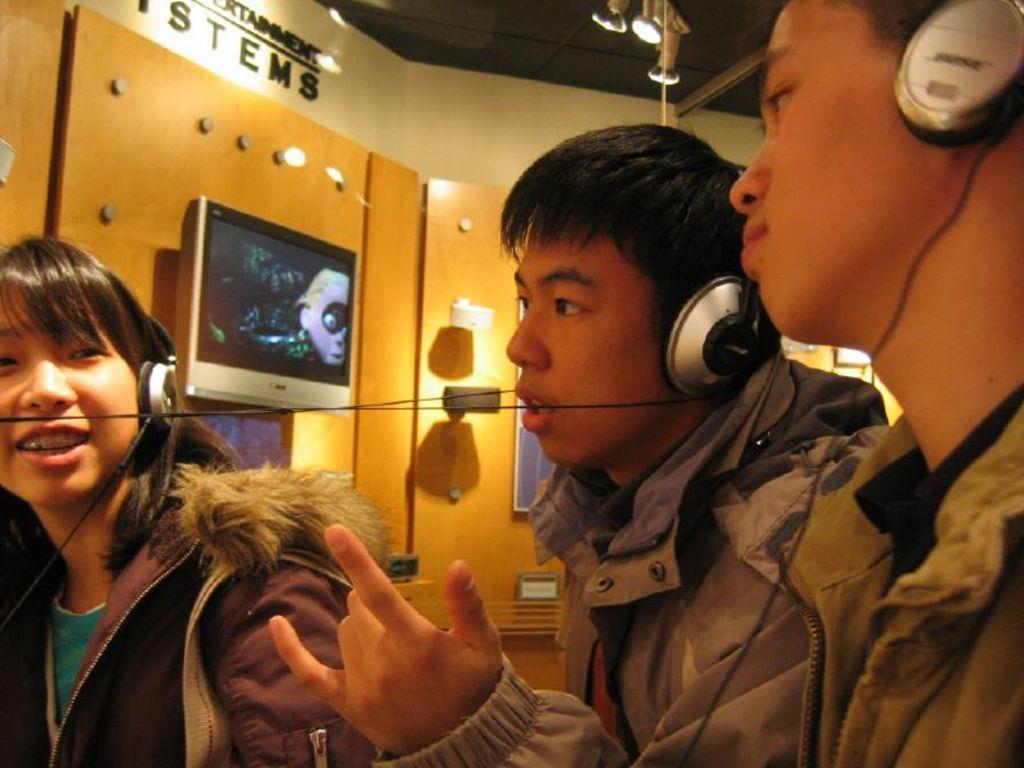In one or two sentences, can you explain what this image depicts? There are three people wore headsets. In the background we can see wall,television and light. At the top we can see lights. 